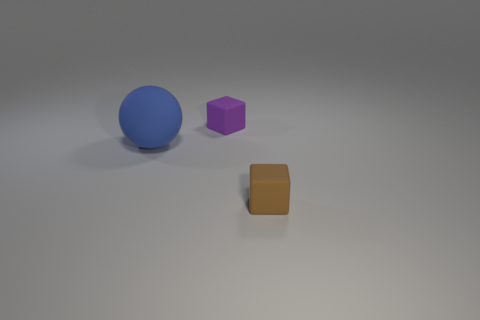Add 3 big matte objects. How many objects exist? 6 Subtract all blocks. How many objects are left? 1 Add 1 tiny purple things. How many tiny purple things are left? 2 Add 1 brown rubber objects. How many brown rubber objects exist? 2 Subtract 0 gray balls. How many objects are left? 3 Subtract all large blue things. Subtract all big blue spheres. How many objects are left? 1 